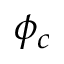<formula> <loc_0><loc_0><loc_500><loc_500>\phi _ { c }</formula> 